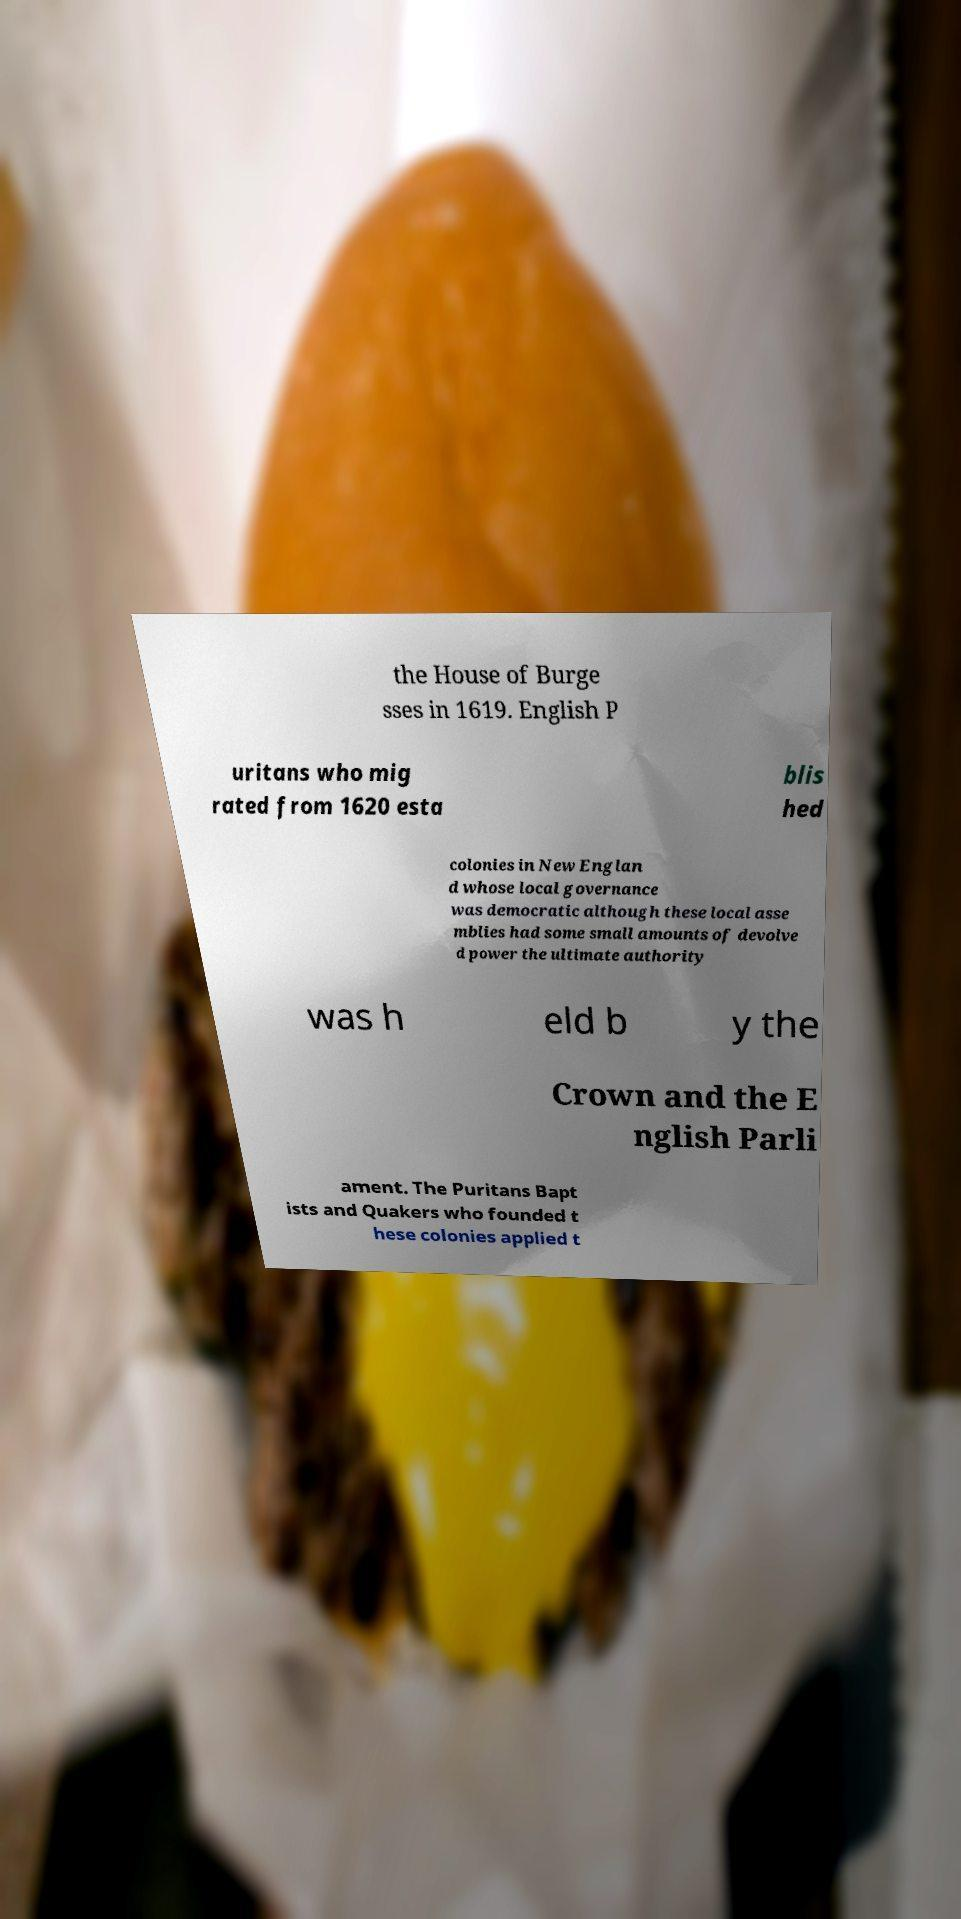I need the written content from this picture converted into text. Can you do that? the House of Burge sses in 1619. English P uritans who mig rated from 1620 esta blis hed colonies in New Englan d whose local governance was democratic although these local asse mblies had some small amounts of devolve d power the ultimate authority was h eld b y the Crown and the E nglish Parli ament. The Puritans Bapt ists and Quakers who founded t hese colonies applied t 